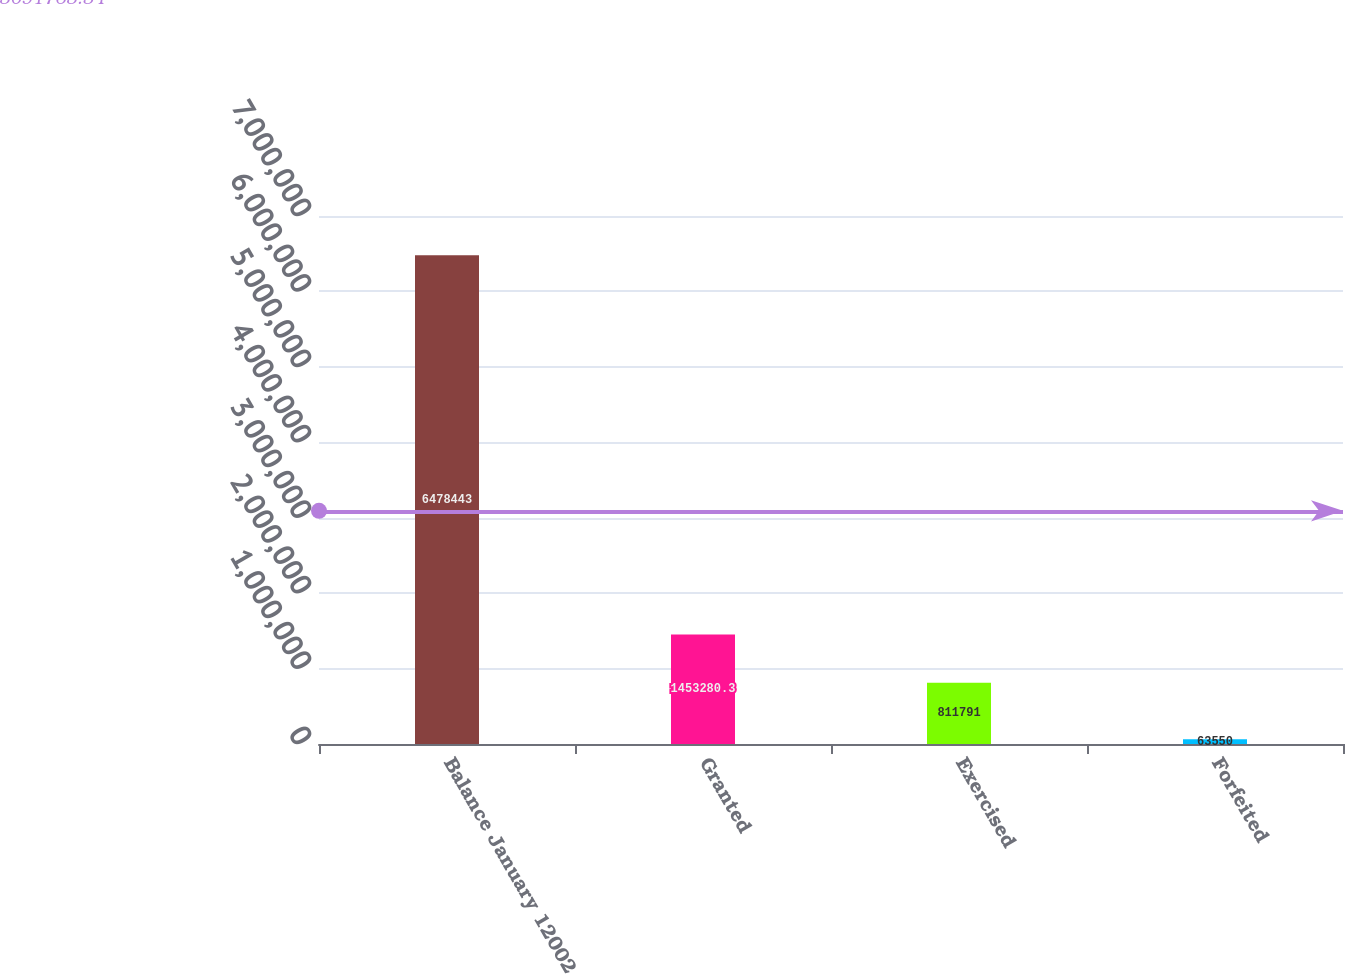Convert chart to OTSL. <chart><loc_0><loc_0><loc_500><loc_500><bar_chart><fcel>Balance January 12002<fcel>Granted<fcel>Exercised<fcel>Forfeited<nl><fcel>6.47844e+06<fcel>1.45328e+06<fcel>811791<fcel>63550<nl></chart> 